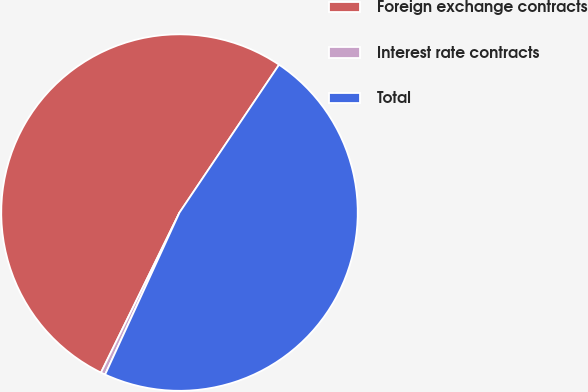<chart> <loc_0><loc_0><loc_500><loc_500><pie_chart><fcel>Foreign exchange contracts<fcel>Interest rate contracts<fcel>Total<nl><fcel>52.17%<fcel>0.41%<fcel>47.42%<nl></chart> 